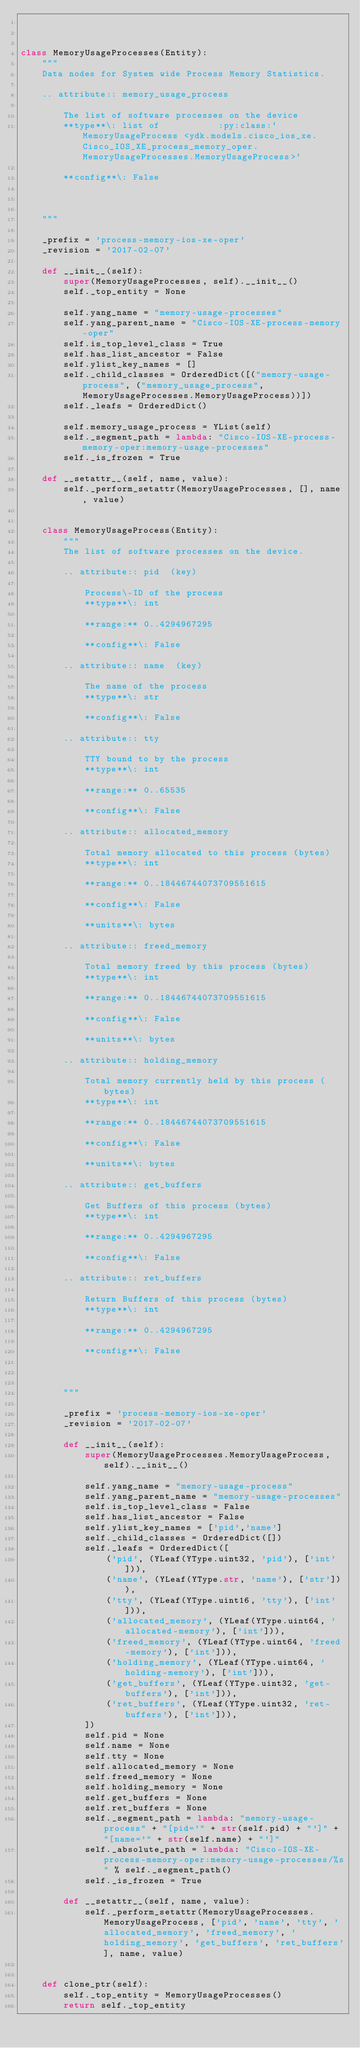<code> <loc_0><loc_0><loc_500><loc_500><_Python_>


class MemoryUsageProcesses(Entity):
    """
    Data nodes for System wide Process Memory Statistics.
    
    .. attribute:: memory_usage_process
    
    	The list of software processes on the device
    	**type**\: list of  		 :py:class:`MemoryUsageProcess <ydk.models.cisco_ios_xe.Cisco_IOS_XE_process_memory_oper.MemoryUsageProcesses.MemoryUsageProcess>`
    
    	**config**\: False
    
    

    """

    _prefix = 'process-memory-ios-xe-oper'
    _revision = '2017-02-07'

    def __init__(self):
        super(MemoryUsageProcesses, self).__init__()
        self._top_entity = None

        self.yang_name = "memory-usage-processes"
        self.yang_parent_name = "Cisco-IOS-XE-process-memory-oper"
        self.is_top_level_class = True
        self.has_list_ancestor = False
        self.ylist_key_names = []
        self._child_classes = OrderedDict([("memory-usage-process", ("memory_usage_process", MemoryUsageProcesses.MemoryUsageProcess))])
        self._leafs = OrderedDict()

        self.memory_usage_process = YList(self)
        self._segment_path = lambda: "Cisco-IOS-XE-process-memory-oper:memory-usage-processes"
        self._is_frozen = True

    def __setattr__(self, name, value):
        self._perform_setattr(MemoryUsageProcesses, [], name, value)


    class MemoryUsageProcess(Entity):
        """
        The list of software processes on the device.
        
        .. attribute:: pid  (key)
        
        	Process\-ID of the process
        	**type**\: int
        
        	**range:** 0..4294967295
        
        	**config**\: False
        
        .. attribute:: name  (key)
        
        	The name of the process
        	**type**\: str
        
        	**config**\: False
        
        .. attribute:: tty
        
        	TTY bound to by the process
        	**type**\: int
        
        	**range:** 0..65535
        
        	**config**\: False
        
        .. attribute:: allocated_memory
        
        	Total memory allocated to this process (bytes)
        	**type**\: int
        
        	**range:** 0..18446744073709551615
        
        	**config**\: False
        
        	**units**\: bytes
        
        .. attribute:: freed_memory
        
        	Total memory freed by this process (bytes)
        	**type**\: int
        
        	**range:** 0..18446744073709551615
        
        	**config**\: False
        
        	**units**\: bytes
        
        .. attribute:: holding_memory
        
        	Total memory currently held by this process (bytes)
        	**type**\: int
        
        	**range:** 0..18446744073709551615
        
        	**config**\: False
        
        	**units**\: bytes
        
        .. attribute:: get_buffers
        
        	Get Buffers of this process (bytes)
        	**type**\: int
        
        	**range:** 0..4294967295
        
        	**config**\: False
        
        .. attribute:: ret_buffers
        
        	Return Buffers of this process (bytes)
        	**type**\: int
        
        	**range:** 0..4294967295
        
        	**config**\: False
        
        

        """

        _prefix = 'process-memory-ios-xe-oper'
        _revision = '2017-02-07'

        def __init__(self):
            super(MemoryUsageProcesses.MemoryUsageProcess, self).__init__()

            self.yang_name = "memory-usage-process"
            self.yang_parent_name = "memory-usage-processes"
            self.is_top_level_class = False
            self.has_list_ancestor = False
            self.ylist_key_names = ['pid','name']
            self._child_classes = OrderedDict([])
            self._leafs = OrderedDict([
                ('pid', (YLeaf(YType.uint32, 'pid'), ['int'])),
                ('name', (YLeaf(YType.str, 'name'), ['str'])),
                ('tty', (YLeaf(YType.uint16, 'tty'), ['int'])),
                ('allocated_memory', (YLeaf(YType.uint64, 'allocated-memory'), ['int'])),
                ('freed_memory', (YLeaf(YType.uint64, 'freed-memory'), ['int'])),
                ('holding_memory', (YLeaf(YType.uint64, 'holding-memory'), ['int'])),
                ('get_buffers', (YLeaf(YType.uint32, 'get-buffers'), ['int'])),
                ('ret_buffers', (YLeaf(YType.uint32, 'ret-buffers'), ['int'])),
            ])
            self.pid = None
            self.name = None
            self.tty = None
            self.allocated_memory = None
            self.freed_memory = None
            self.holding_memory = None
            self.get_buffers = None
            self.ret_buffers = None
            self._segment_path = lambda: "memory-usage-process" + "[pid='" + str(self.pid) + "']" + "[name='" + str(self.name) + "']"
            self._absolute_path = lambda: "Cisco-IOS-XE-process-memory-oper:memory-usage-processes/%s" % self._segment_path()
            self._is_frozen = True

        def __setattr__(self, name, value):
            self._perform_setattr(MemoryUsageProcesses.MemoryUsageProcess, ['pid', 'name', 'tty', 'allocated_memory', 'freed_memory', 'holding_memory', 'get_buffers', 'ret_buffers'], name, value)


    def clone_ptr(self):
        self._top_entity = MemoryUsageProcesses()
        return self._top_entity



</code> 